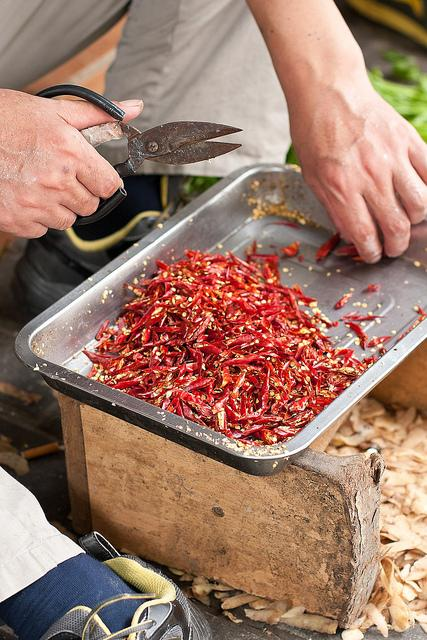Which is widely used in many cuisines as a spice to add pungent 'heat' to dishes? Please explain your reasoning. chilies. They are spicy and you can see the actual vegetable and it's seeds being cut. 